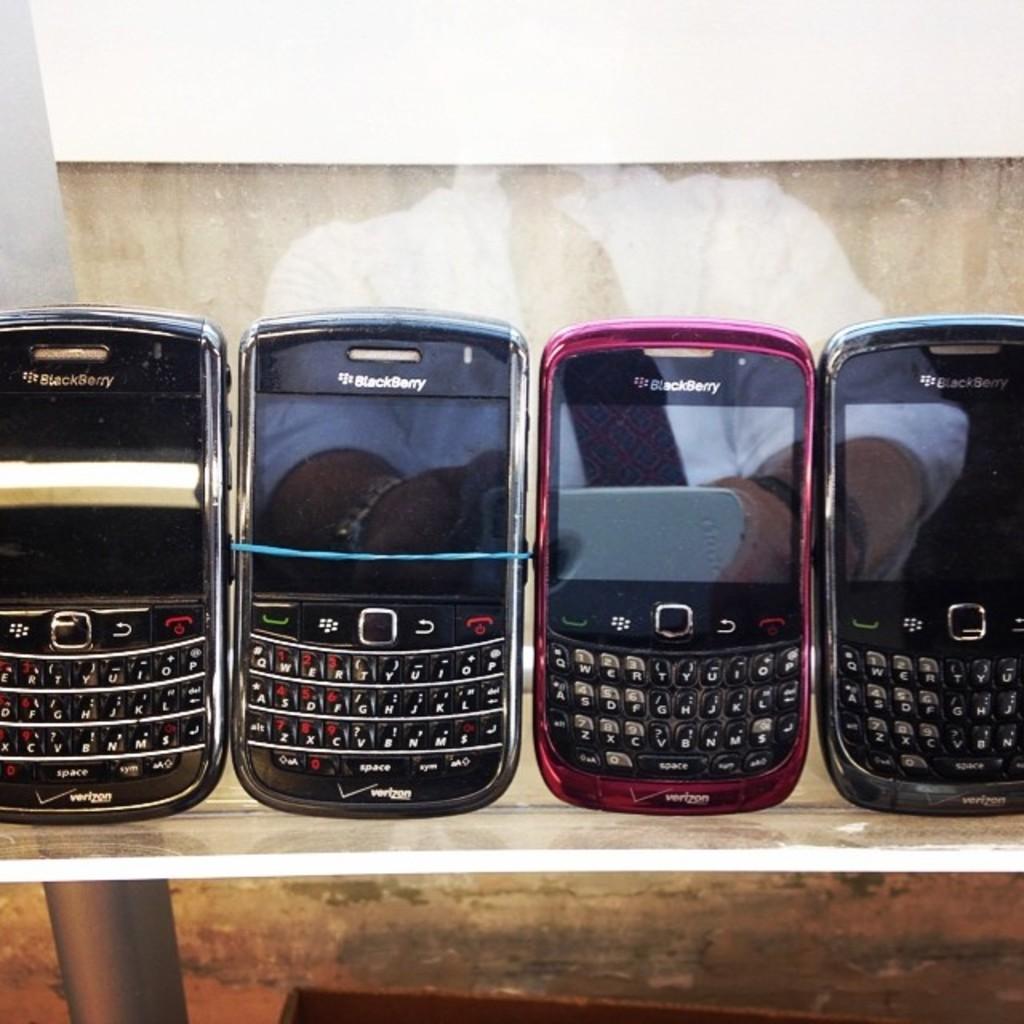What brand are these phones?
Your answer should be compact. Blackberry. What service is the phone for?
Make the answer very short. Verizon. 